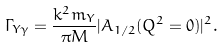<formula> <loc_0><loc_0><loc_500><loc_500>\Gamma _ { Y \gamma } = \frac { k ^ { 2 } m _ { Y } } { \pi M } | A _ { 1 / 2 } ( Q ^ { 2 } = 0 ) | ^ { 2 } .</formula> 